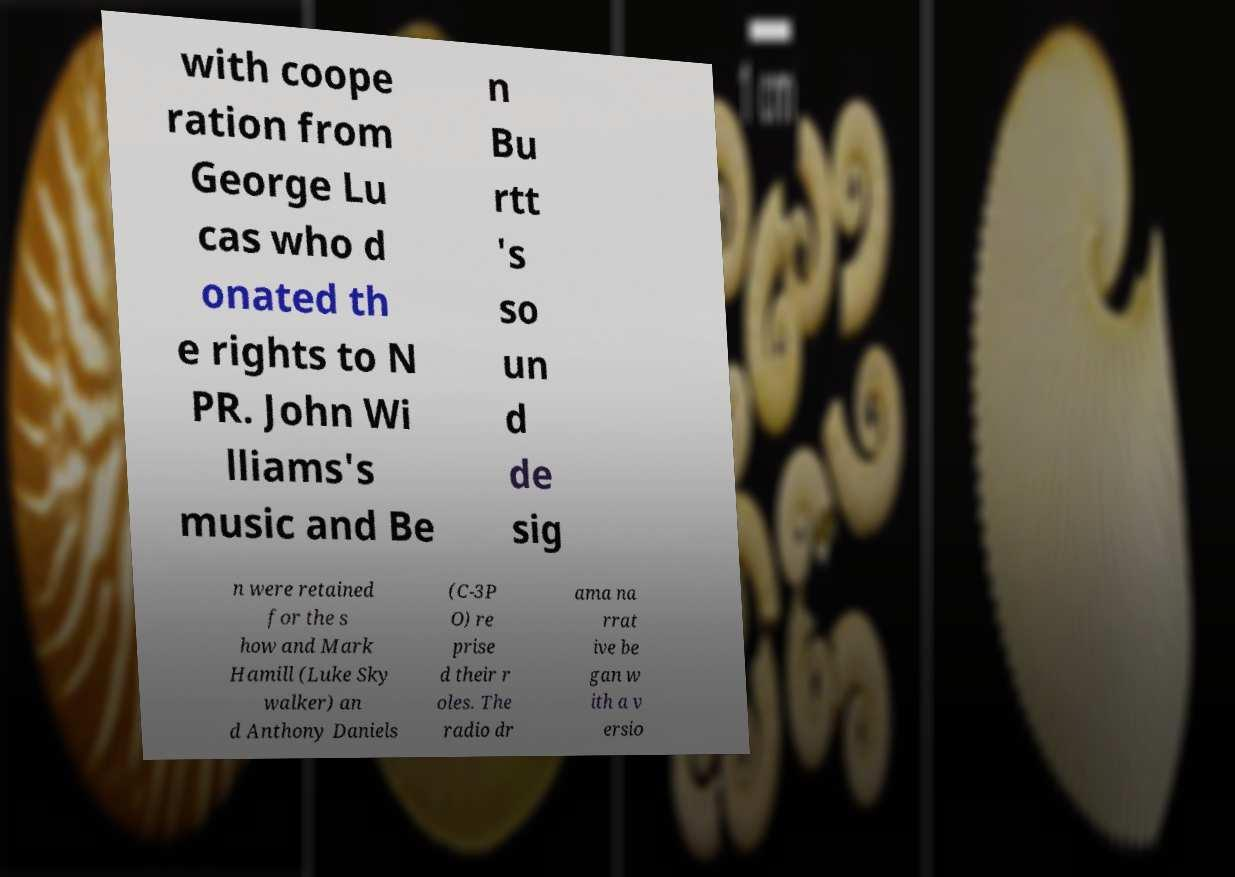Please identify and transcribe the text found in this image. with coope ration from George Lu cas who d onated th e rights to N PR. John Wi lliams's music and Be n Bu rtt 's so un d de sig n were retained for the s how and Mark Hamill (Luke Sky walker) an d Anthony Daniels (C-3P O) re prise d their r oles. The radio dr ama na rrat ive be gan w ith a v ersio 